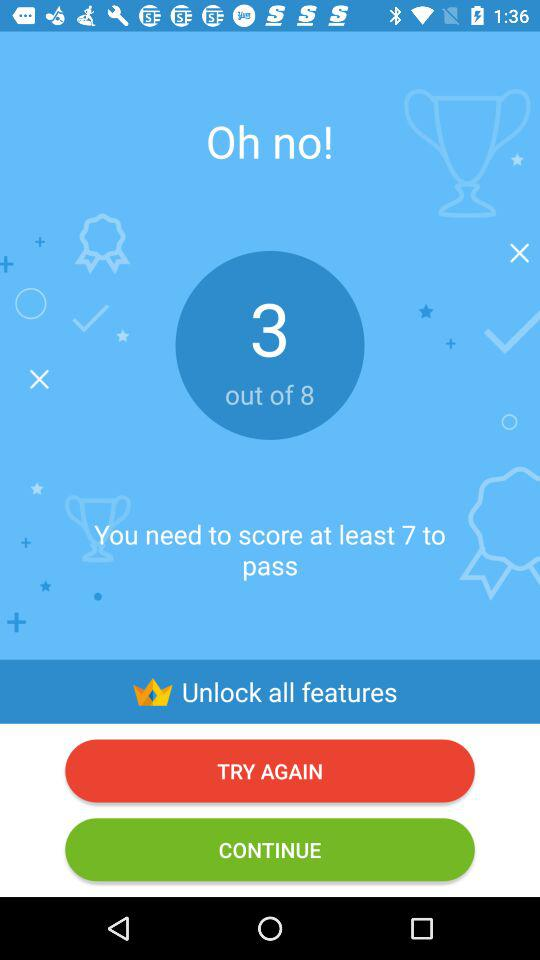How many points did I score?
Answer the question using a single word or phrase. 3 